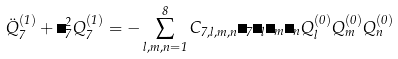<formula> <loc_0><loc_0><loc_500><loc_500>\ddot { Q } _ { 7 } ^ { ( 1 ) } + \Omega _ { 7 } ^ { 2 } Q _ { 7 } ^ { ( 1 ) } = - \sum _ { l , m , n = 1 } ^ { 8 } C _ { 7 , l , m , n } \Omega _ { 7 } \Omega _ { l } \Omega _ { m } \Omega _ { n } Q _ { l } ^ { ( 0 ) } Q _ { m } ^ { ( 0 ) } Q _ { n } ^ { ( 0 ) }</formula> 